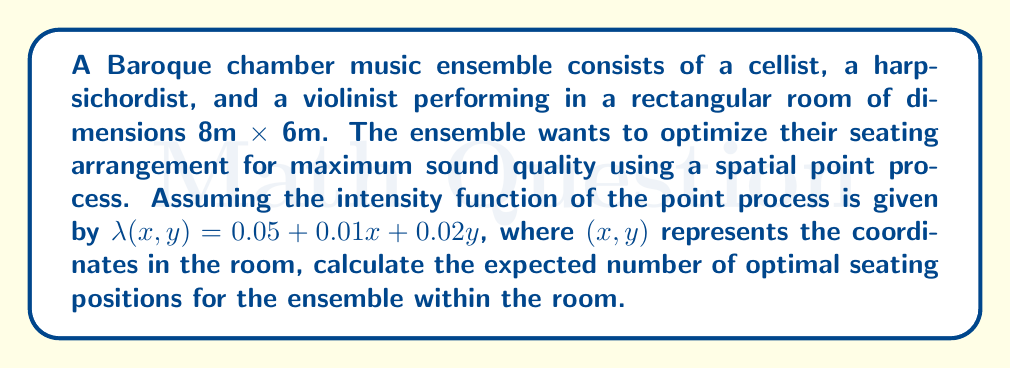Show me your answer to this math problem. To solve this problem, we need to follow these steps:

1) The intensity function $\lambda(x,y)$ represents the expected number of points per unit area at location $(x,y)$.

2) To find the expected number of points (optimal seating positions) in the entire room, we need to integrate the intensity function over the room's area:

   $$ E[N] = \int\int_A \lambda(x,y) \, dx \, dy $$

   where $A$ is the area of the room.

3) Given the room dimensions, we integrate from 0 to 8 for $x$ and from 0 to 6 for $y$:

   $$ E[N] = \int_0^6 \int_0^8 (0.05 + 0.01x + 0.02y) \, dx \, dy $$

4) Let's solve the inner integral first:

   $$ \int_0^8 (0.05 + 0.01x + 0.02y) \, dx = [0.05x + 0.005x^2 + 0.02xy]_0^8 $$
   $$ = (0.4 + 0.32 + 0.16y) - 0 = 0.72 + 0.16y $$

5) Now, let's solve the outer integral:

   $$ E[N] = \int_0^6 (0.72 + 0.16y) \, dy = [0.72y + 0.08y^2]_0^6 $$
   $$ = (4.32 + 2.88) - 0 = 7.2 $$

Therefore, the expected number of optimal seating positions within the room is 7.2.
Answer: 7.2 